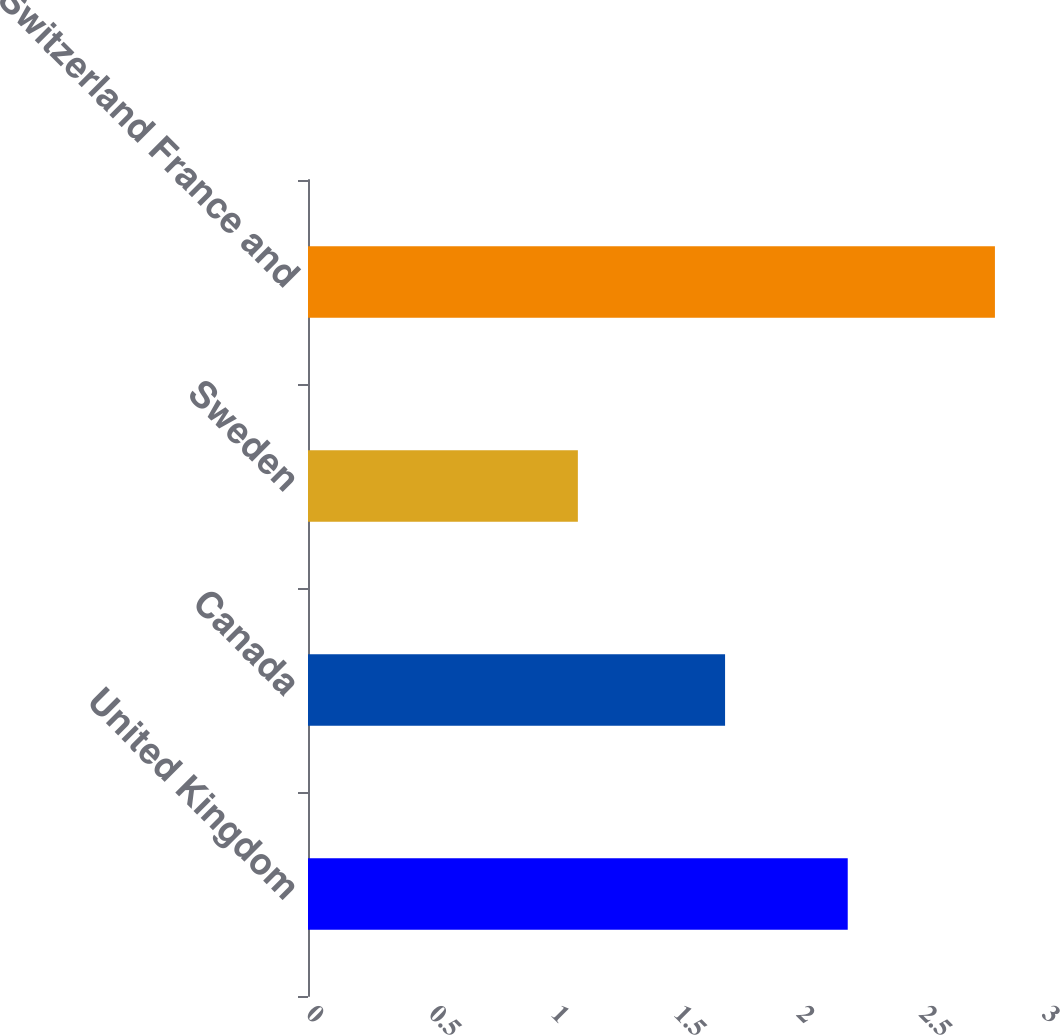Convert chart to OTSL. <chart><loc_0><loc_0><loc_500><loc_500><bar_chart><fcel>United Kingdom<fcel>Canada<fcel>Sweden<fcel>Switzerland France and<nl><fcel>2.2<fcel>1.7<fcel>1.1<fcel>2.8<nl></chart> 